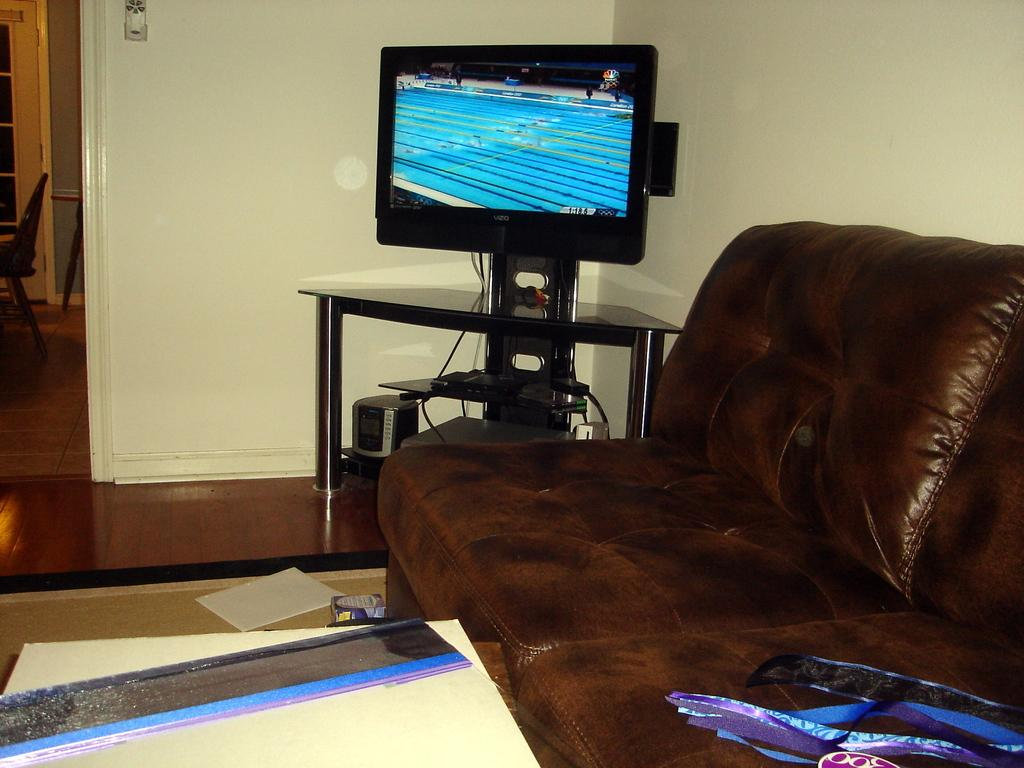What type of space is depicted in the image? There is a room in the image. What furniture is present in the room? There is a sofa in the room. What electronic device is in the room? There is a TV in the room. How is the TV positioned in the room? The TV is placed on a table. What can be seen in the background of the room? There is a wall in the background of the room. What is the name of the person who designed the sofa in the image? There is no information about the designer of the sofa in the image, so we cannot provide a name. 